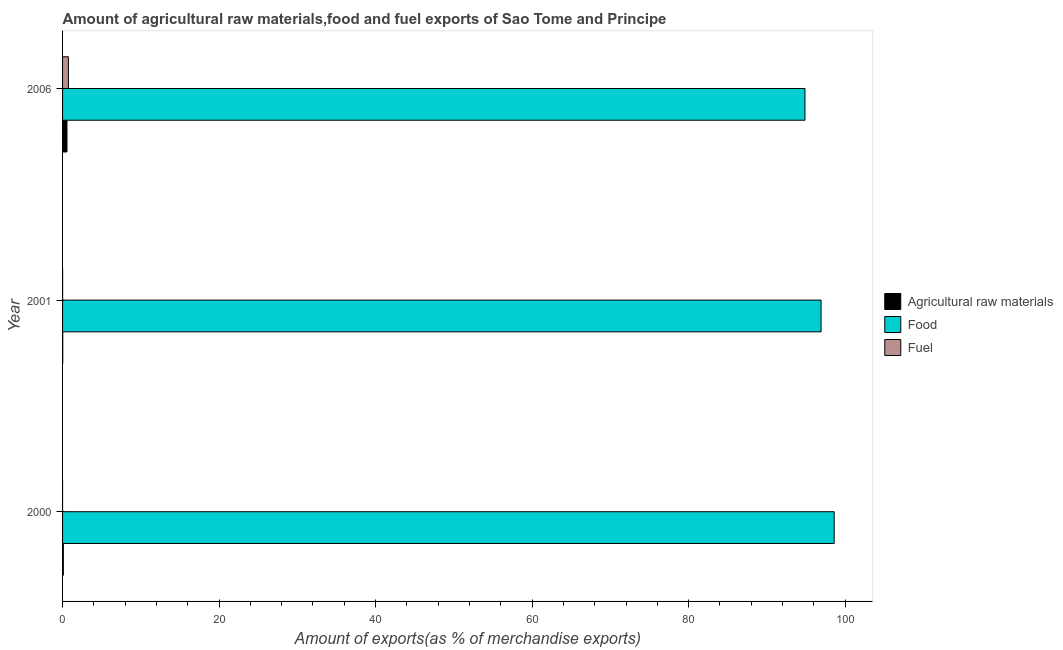How many different coloured bars are there?
Offer a very short reply. 3. Are the number of bars per tick equal to the number of legend labels?
Offer a very short reply. Yes. Are the number of bars on each tick of the Y-axis equal?
Your answer should be compact. Yes. How many bars are there on the 2nd tick from the top?
Provide a short and direct response. 3. How many bars are there on the 1st tick from the bottom?
Your answer should be very brief. 3. What is the label of the 1st group of bars from the top?
Provide a short and direct response. 2006. What is the percentage of fuel exports in 2006?
Your answer should be compact. 0.75. Across all years, what is the maximum percentage of fuel exports?
Make the answer very short. 0.75. Across all years, what is the minimum percentage of raw materials exports?
Offer a very short reply. 0.02. In which year was the percentage of raw materials exports maximum?
Provide a short and direct response. 2006. What is the total percentage of food exports in the graph?
Provide a succinct answer. 290.39. What is the difference between the percentage of fuel exports in 2000 and that in 2001?
Your response must be concise. -0.01. What is the difference between the percentage of food exports in 2006 and the percentage of raw materials exports in 2000?
Offer a very short reply. 94.77. What is the average percentage of food exports per year?
Make the answer very short. 96.8. In the year 2000, what is the difference between the percentage of food exports and percentage of fuel exports?
Give a very brief answer. 98.6. In how many years, is the percentage of raw materials exports greater than 40 %?
Offer a terse response. 0. What is the ratio of the percentage of raw materials exports in 2000 to that in 2001?
Offer a very short reply. 4.28. Is the percentage of raw materials exports in 2000 less than that in 2001?
Your response must be concise. No. Is the difference between the percentage of food exports in 2000 and 2001 greater than the difference between the percentage of fuel exports in 2000 and 2001?
Provide a short and direct response. Yes. What is the difference between the highest and the second highest percentage of fuel exports?
Keep it short and to the point. 0.74. Is the sum of the percentage of food exports in 2000 and 2001 greater than the maximum percentage of raw materials exports across all years?
Your response must be concise. Yes. What does the 3rd bar from the top in 2001 represents?
Make the answer very short. Agricultural raw materials. What does the 3rd bar from the bottom in 2000 represents?
Ensure brevity in your answer.  Fuel. Is it the case that in every year, the sum of the percentage of raw materials exports and percentage of food exports is greater than the percentage of fuel exports?
Your answer should be compact. Yes. How many years are there in the graph?
Provide a succinct answer. 3. Are the values on the major ticks of X-axis written in scientific E-notation?
Provide a succinct answer. No. Does the graph contain grids?
Make the answer very short. No. Where does the legend appear in the graph?
Give a very brief answer. Center right. How many legend labels are there?
Offer a very short reply. 3. What is the title of the graph?
Provide a short and direct response. Amount of agricultural raw materials,food and fuel exports of Sao Tome and Principe. Does "Czech Republic" appear as one of the legend labels in the graph?
Offer a terse response. No. What is the label or title of the X-axis?
Offer a very short reply. Amount of exports(as % of merchandise exports). What is the label or title of the Y-axis?
Your answer should be compact. Year. What is the Amount of exports(as % of merchandise exports) of Agricultural raw materials in 2000?
Your response must be concise. 0.1. What is the Amount of exports(as % of merchandise exports) of Food in 2000?
Your response must be concise. 98.6. What is the Amount of exports(as % of merchandise exports) of Fuel in 2000?
Provide a short and direct response. 0. What is the Amount of exports(as % of merchandise exports) in Agricultural raw materials in 2001?
Ensure brevity in your answer.  0.02. What is the Amount of exports(as % of merchandise exports) of Food in 2001?
Your response must be concise. 96.92. What is the Amount of exports(as % of merchandise exports) in Fuel in 2001?
Provide a short and direct response. 0.01. What is the Amount of exports(as % of merchandise exports) in Agricultural raw materials in 2006?
Give a very brief answer. 0.56. What is the Amount of exports(as % of merchandise exports) of Food in 2006?
Your answer should be very brief. 94.87. What is the Amount of exports(as % of merchandise exports) of Fuel in 2006?
Your answer should be compact. 0.75. Across all years, what is the maximum Amount of exports(as % of merchandise exports) in Agricultural raw materials?
Ensure brevity in your answer.  0.56. Across all years, what is the maximum Amount of exports(as % of merchandise exports) in Food?
Provide a succinct answer. 98.6. Across all years, what is the maximum Amount of exports(as % of merchandise exports) of Fuel?
Offer a very short reply. 0.75. Across all years, what is the minimum Amount of exports(as % of merchandise exports) in Agricultural raw materials?
Offer a very short reply. 0.02. Across all years, what is the minimum Amount of exports(as % of merchandise exports) of Food?
Keep it short and to the point. 94.87. Across all years, what is the minimum Amount of exports(as % of merchandise exports) in Fuel?
Ensure brevity in your answer.  0. What is the total Amount of exports(as % of merchandise exports) of Agricultural raw materials in the graph?
Offer a terse response. 0.68. What is the total Amount of exports(as % of merchandise exports) of Food in the graph?
Offer a terse response. 290.39. What is the total Amount of exports(as % of merchandise exports) in Fuel in the graph?
Provide a succinct answer. 0.75. What is the difference between the Amount of exports(as % of merchandise exports) in Agricultural raw materials in 2000 and that in 2001?
Provide a succinct answer. 0.07. What is the difference between the Amount of exports(as % of merchandise exports) in Food in 2000 and that in 2001?
Provide a succinct answer. 1.68. What is the difference between the Amount of exports(as % of merchandise exports) in Fuel in 2000 and that in 2001?
Make the answer very short. -0.01. What is the difference between the Amount of exports(as % of merchandise exports) of Agricultural raw materials in 2000 and that in 2006?
Keep it short and to the point. -0.47. What is the difference between the Amount of exports(as % of merchandise exports) of Food in 2000 and that in 2006?
Make the answer very short. 3.73. What is the difference between the Amount of exports(as % of merchandise exports) in Fuel in 2000 and that in 2006?
Your response must be concise. -0.75. What is the difference between the Amount of exports(as % of merchandise exports) of Agricultural raw materials in 2001 and that in 2006?
Provide a short and direct response. -0.54. What is the difference between the Amount of exports(as % of merchandise exports) of Food in 2001 and that in 2006?
Provide a short and direct response. 2.05. What is the difference between the Amount of exports(as % of merchandise exports) of Fuel in 2001 and that in 2006?
Provide a succinct answer. -0.74. What is the difference between the Amount of exports(as % of merchandise exports) of Agricultural raw materials in 2000 and the Amount of exports(as % of merchandise exports) of Food in 2001?
Offer a terse response. -96.82. What is the difference between the Amount of exports(as % of merchandise exports) in Agricultural raw materials in 2000 and the Amount of exports(as % of merchandise exports) in Fuel in 2001?
Ensure brevity in your answer.  0.09. What is the difference between the Amount of exports(as % of merchandise exports) of Food in 2000 and the Amount of exports(as % of merchandise exports) of Fuel in 2001?
Ensure brevity in your answer.  98.59. What is the difference between the Amount of exports(as % of merchandise exports) in Agricultural raw materials in 2000 and the Amount of exports(as % of merchandise exports) in Food in 2006?
Provide a short and direct response. -94.77. What is the difference between the Amount of exports(as % of merchandise exports) in Agricultural raw materials in 2000 and the Amount of exports(as % of merchandise exports) in Fuel in 2006?
Offer a very short reply. -0.65. What is the difference between the Amount of exports(as % of merchandise exports) in Food in 2000 and the Amount of exports(as % of merchandise exports) in Fuel in 2006?
Keep it short and to the point. 97.85. What is the difference between the Amount of exports(as % of merchandise exports) in Agricultural raw materials in 2001 and the Amount of exports(as % of merchandise exports) in Food in 2006?
Your answer should be compact. -94.84. What is the difference between the Amount of exports(as % of merchandise exports) of Agricultural raw materials in 2001 and the Amount of exports(as % of merchandise exports) of Fuel in 2006?
Give a very brief answer. -0.72. What is the difference between the Amount of exports(as % of merchandise exports) in Food in 2001 and the Amount of exports(as % of merchandise exports) in Fuel in 2006?
Give a very brief answer. 96.17. What is the average Amount of exports(as % of merchandise exports) of Agricultural raw materials per year?
Your answer should be compact. 0.23. What is the average Amount of exports(as % of merchandise exports) of Food per year?
Your answer should be very brief. 96.8. What is the average Amount of exports(as % of merchandise exports) in Fuel per year?
Your answer should be compact. 0.25. In the year 2000, what is the difference between the Amount of exports(as % of merchandise exports) in Agricultural raw materials and Amount of exports(as % of merchandise exports) in Food?
Make the answer very short. -98.5. In the year 2000, what is the difference between the Amount of exports(as % of merchandise exports) in Agricultural raw materials and Amount of exports(as % of merchandise exports) in Fuel?
Your response must be concise. 0.1. In the year 2000, what is the difference between the Amount of exports(as % of merchandise exports) in Food and Amount of exports(as % of merchandise exports) in Fuel?
Offer a very short reply. 98.6. In the year 2001, what is the difference between the Amount of exports(as % of merchandise exports) of Agricultural raw materials and Amount of exports(as % of merchandise exports) of Food?
Your answer should be compact. -96.9. In the year 2001, what is the difference between the Amount of exports(as % of merchandise exports) of Agricultural raw materials and Amount of exports(as % of merchandise exports) of Fuel?
Give a very brief answer. 0.02. In the year 2001, what is the difference between the Amount of exports(as % of merchandise exports) in Food and Amount of exports(as % of merchandise exports) in Fuel?
Offer a terse response. 96.92. In the year 2006, what is the difference between the Amount of exports(as % of merchandise exports) of Agricultural raw materials and Amount of exports(as % of merchandise exports) of Food?
Keep it short and to the point. -94.31. In the year 2006, what is the difference between the Amount of exports(as % of merchandise exports) of Agricultural raw materials and Amount of exports(as % of merchandise exports) of Fuel?
Provide a succinct answer. -0.18. In the year 2006, what is the difference between the Amount of exports(as % of merchandise exports) in Food and Amount of exports(as % of merchandise exports) in Fuel?
Your answer should be compact. 94.12. What is the ratio of the Amount of exports(as % of merchandise exports) of Agricultural raw materials in 2000 to that in 2001?
Provide a succinct answer. 4.28. What is the ratio of the Amount of exports(as % of merchandise exports) of Food in 2000 to that in 2001?
Provide a succinct answer. 1.02. What is the ratio of the Amount of exports(as % of merchandise exports) in Fuel in 2000 to that in 2001?
Your answer should be very brief. 0.02. What is the ratio of the Amount of exports(as % of merchandise exports) in Agricultural raw materials in 2000 to that in 2006?
Your answer should be compact. 0.17. What is the ratio of the Amount of exports(as % of merchandise exports) in Food in 2000 to that in 2006?
Offer a very short reply. 1.04. What is the ratio of the Amount of exports(as % of merchandise exports) in Fuel in 2000 to that in 2006?
Make the answer very short. 0. What is the ratio of the Amount of exports(as % of merchandise exports) of Agricultural raw materials in 2001 to that in 2006?
Give a very brief answer. 0.04. What is the ratio of the Amount of exports(as % of merchandise exports) in Food in 2001 to that in 2006?
Your answer should be compact. 1.02. What is the ratio of the Amount of exports(as % of merchandise exports) of Fuel in 2001 to that in 2006?
Ensure brevity in your answer.  0.01. What is the difference between the highest and the second highest Amount of exports(as % of merchandise exports) in Agricultural raw materials?
Your response must be concise. 0.47. What is the difference between the highest and the second highest Amount of exports(as % of merchandise exports) in Food?
Your answer should be compact. 1.68. What is the difference between the highest and the second highest Amount of exports(as % of merchandise exports) of Fuel?
Keep it short and to the point. 0.74. What is the difference between the highest and the lowest Amount of exports(as % of merchandise exports) of Agricultural raw materials?
Keep it short and to the point. 0.54. What is the difference between the highest and the lowest Amount of exports(as % of merchandise exports) in Food?
Your answer should be compact. 3.73. What is the difference between the highest and the lowest Amount of exports(as % of merchandise exports) of Fuel?
Your response must be concise. 0.75. 